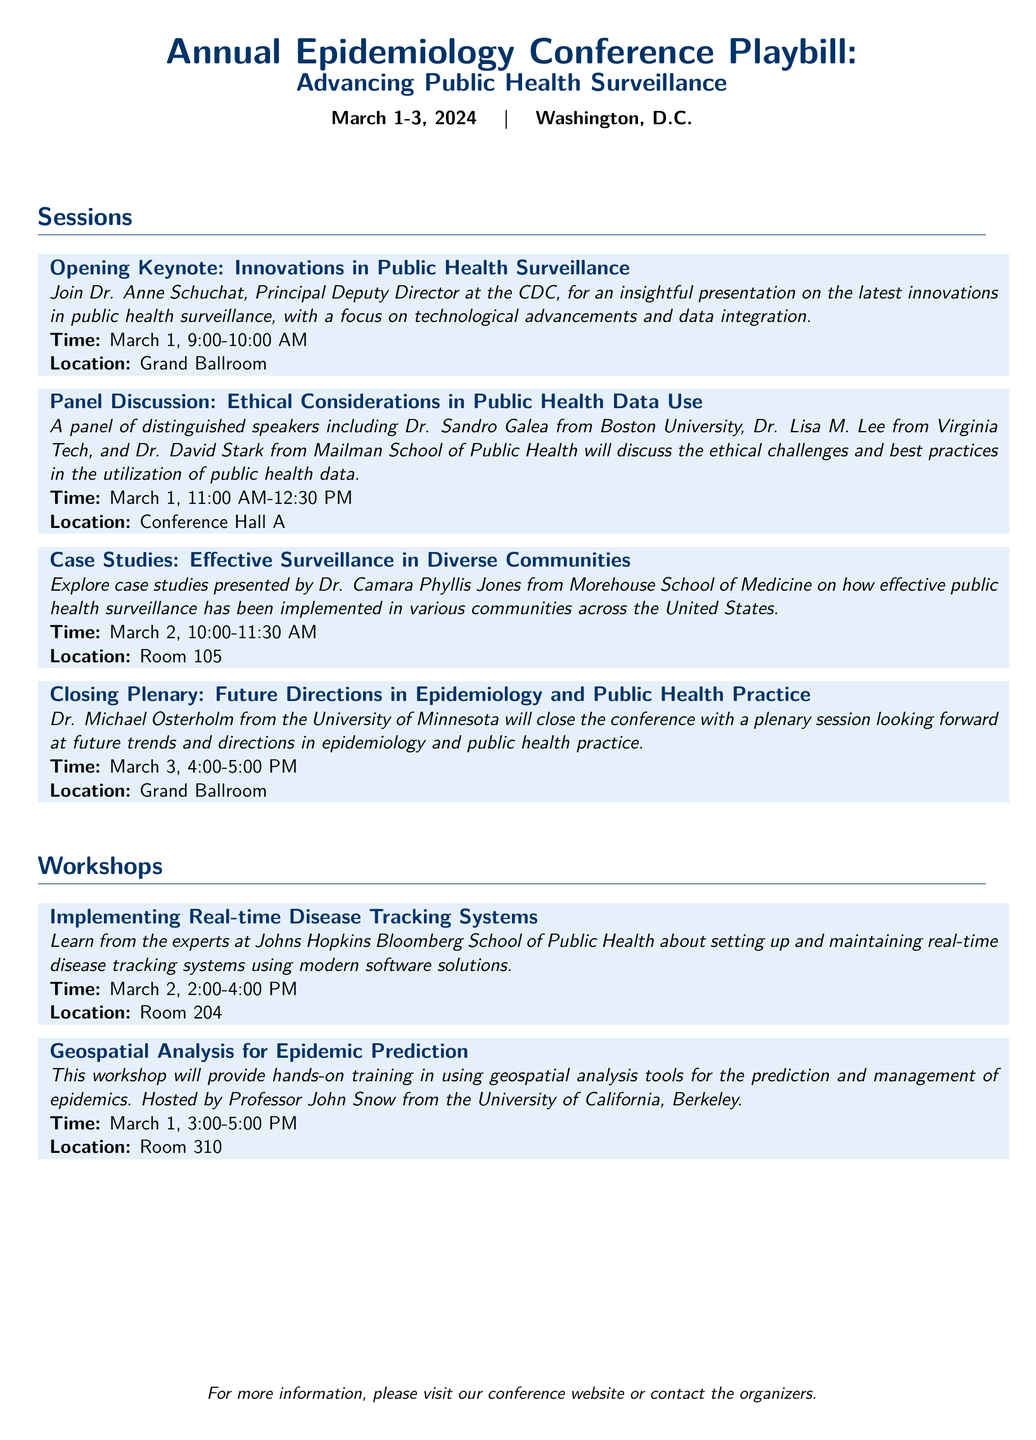What is the location of the Opening Keynote? The Opening Keynote is scheduled to take place in the Grand Ballroom, as stated in the event details.
Answer: Grand Ballroom Who is the speaker for the Case Studies session? Dr. Camara Phyllis Jones is the presenter for the Case Studies session, according to the program.
Answer: Dr. Camara Phyllis Jones When does the Closing Plenary occur? The Closing Plenary is scheduled for March 3, from 4:00 to 5:00 PM, as indicated in the event list.
Answer: March 3, 4:00-5:00 PM What is the focus of the panel discussion? The focus of the panel discussion is on ethical considerations in public health data use, as mentioned in the session description.
Answer: Ethical considerations in public health data use Which university is Professor John Snow associated with? Professor John Snow is associated with the University of California, Berkeley, as detailed in the workshop information.
Answer: University of California, Berkeley What is the total number of days the conference lasts? The conference spans three days, from March 1 to March 3, as outlined in the document.
Answer: 3 What type of training does the Geospatial Analysis workshop provide? The Geospatial Analysis workshop provides hands-on training, as stated in the workshop description.
Answer: Hands-on training What is the primary theme of the conference? The primary theme of the conference is advancing public health surveillance, which is emphasized in the title.
Answer: Advancing Public Health Surveillance 